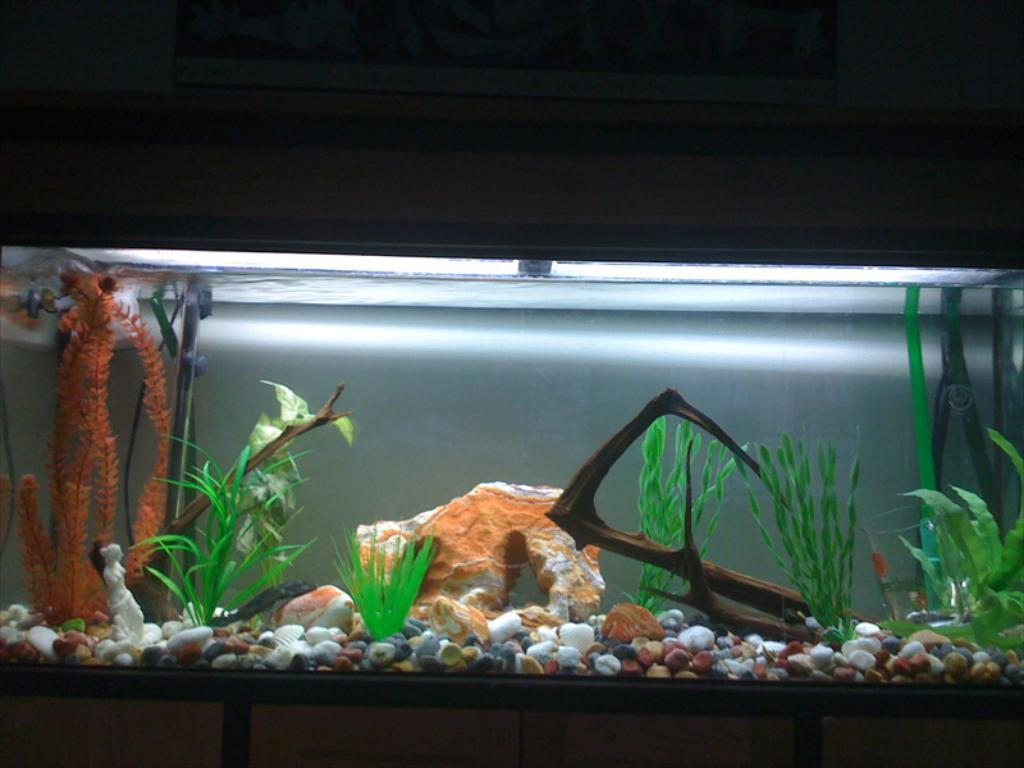What is the main subject of the image? The main subject of the image is an aquarium. What can be found inside the aquarium? The aquarium contains stones, plants, and other objects. Can you describe the background of the image? The background of the image is dark in color. Can you see a tree growing inside the aquarium in the image? No, there is no tree growing inside the aquarium in the image. Is there a stream flowing through the aquarium in the image? No, there is no stream flowing through the aquarium in the image. 